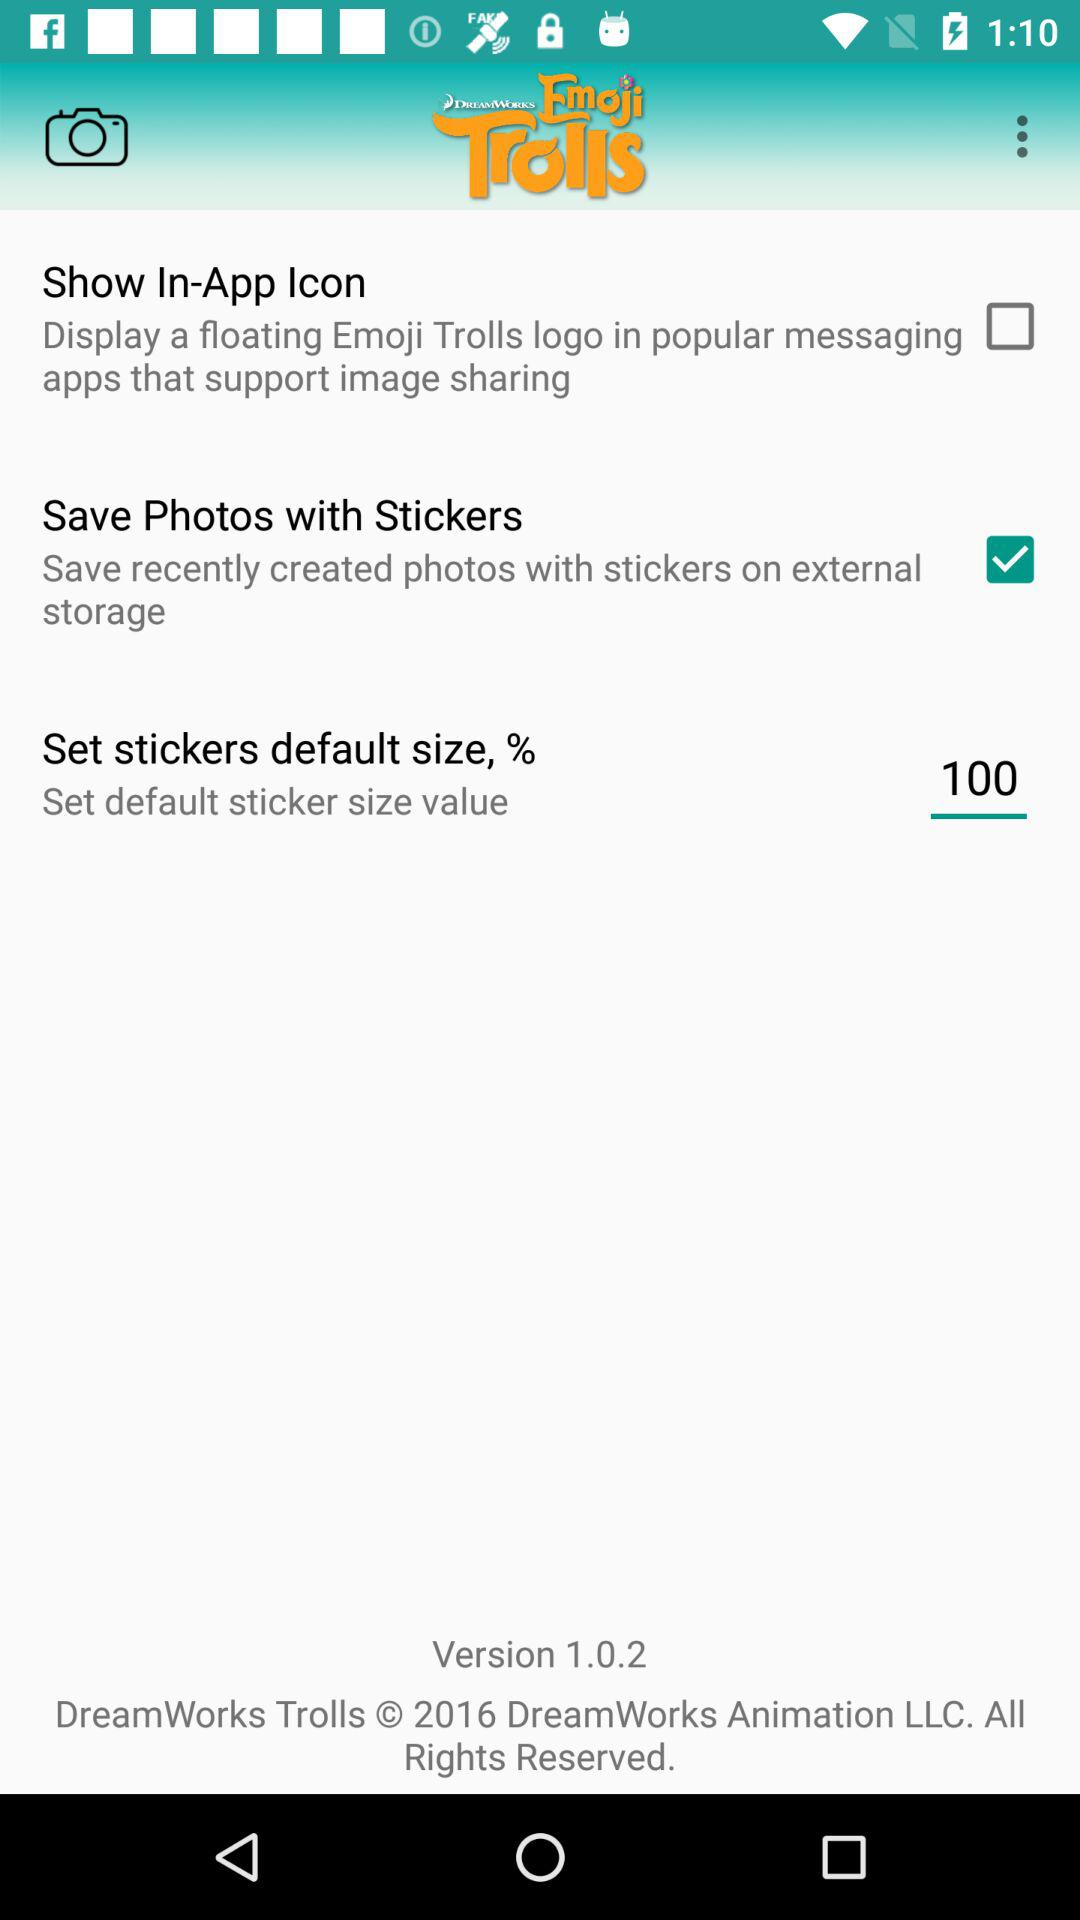Which option should we select to display a floating Emoji Trolls logo in popular messaging apps that support image sharing? You should select the option "Show In-App Icon". 